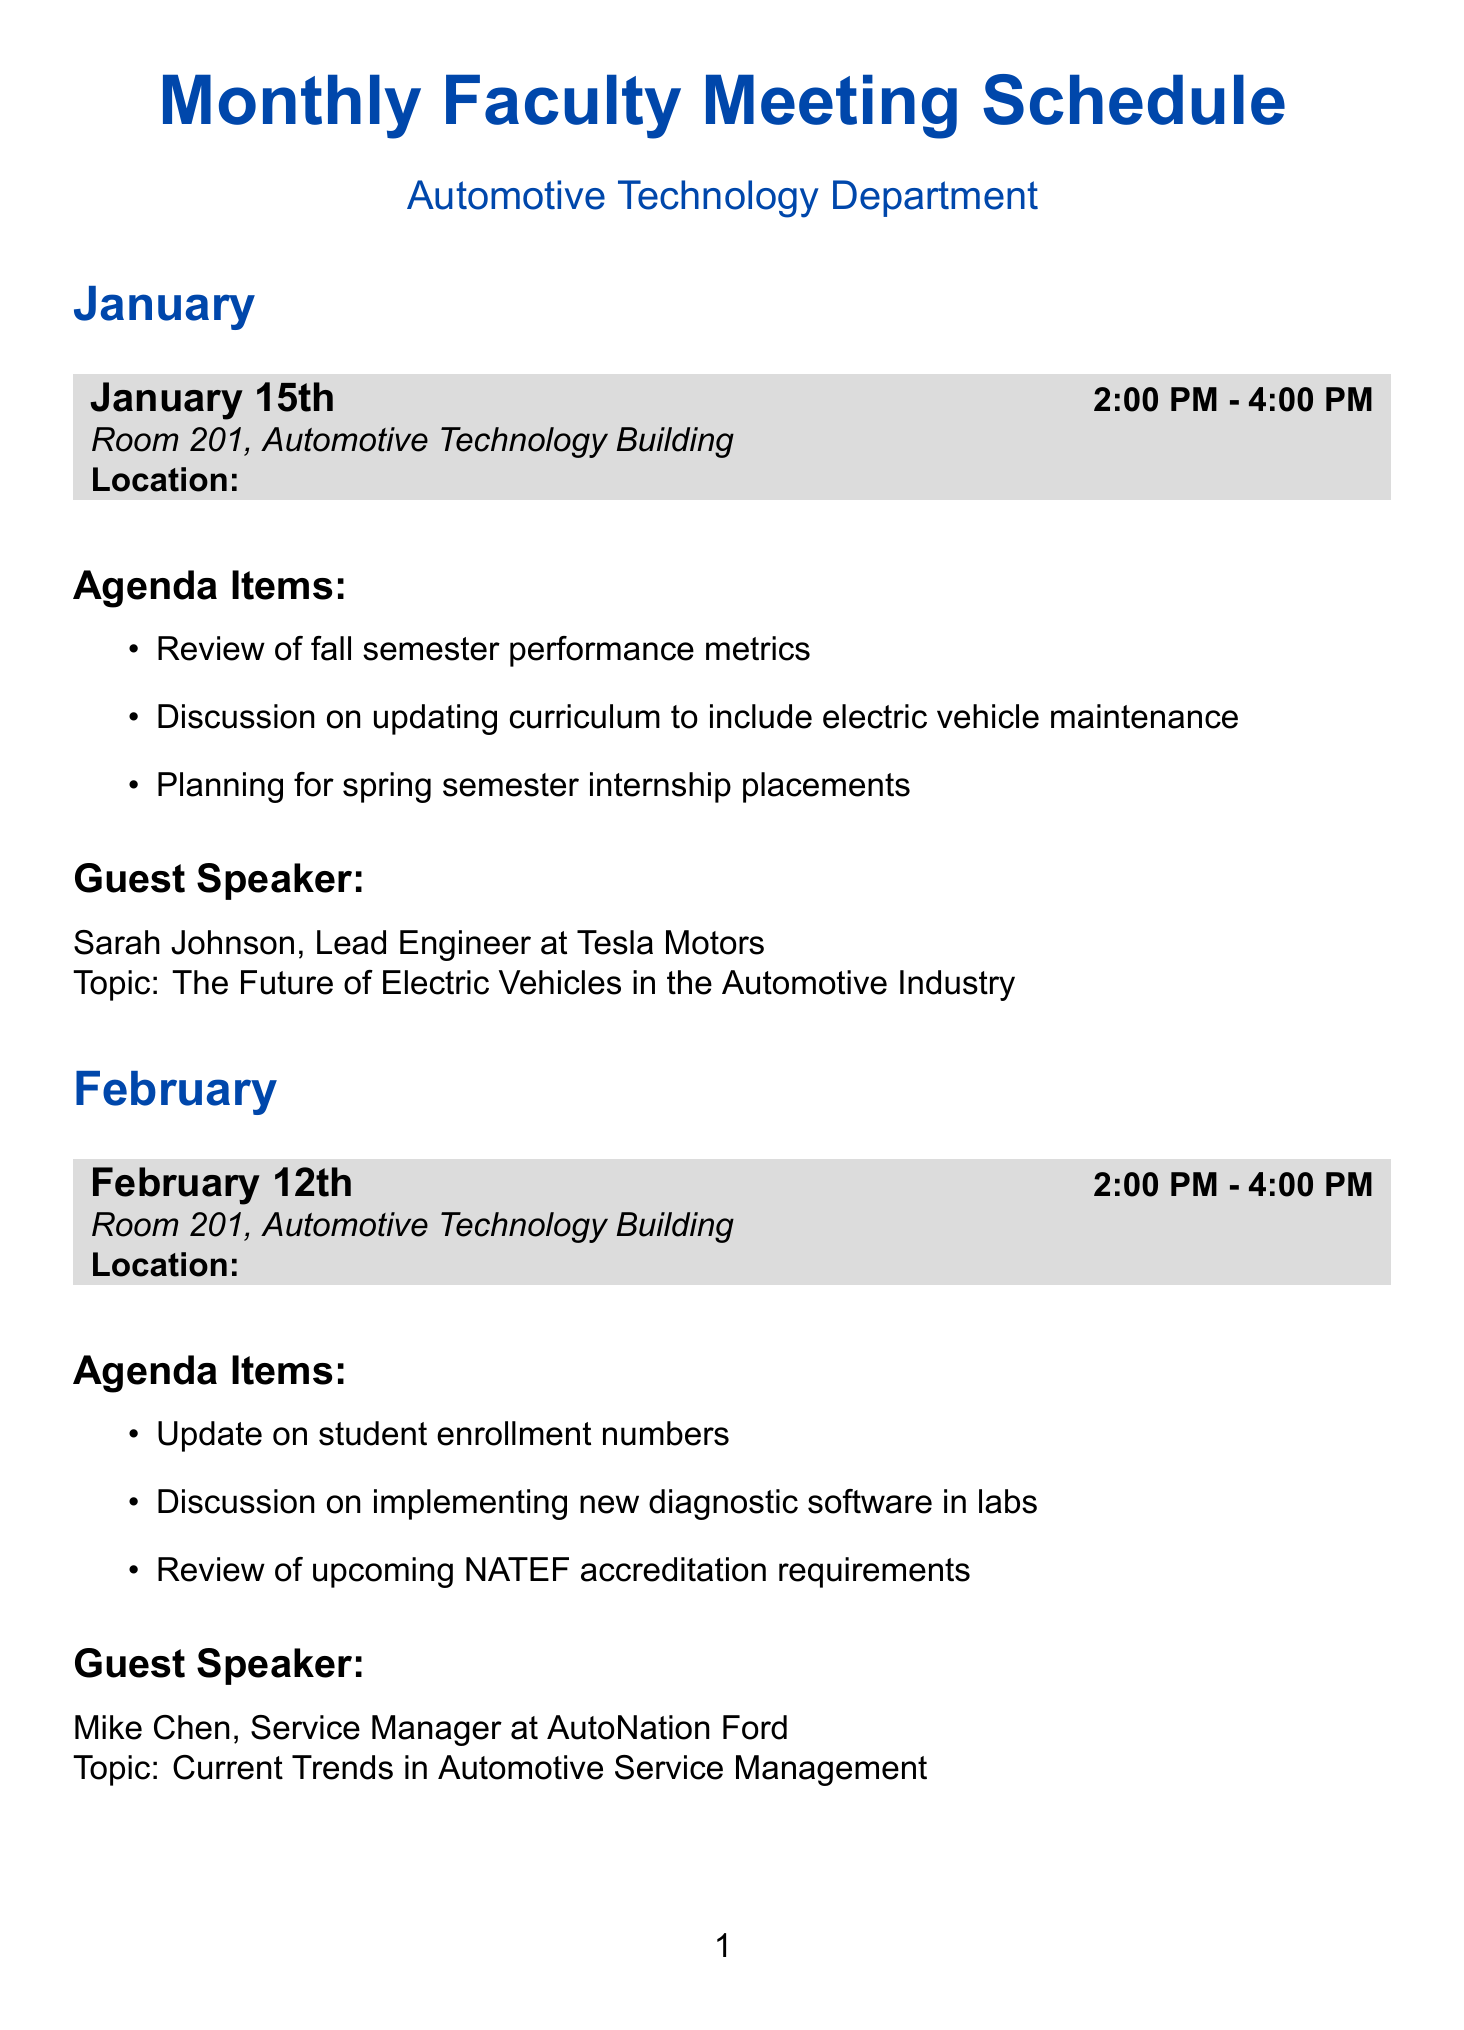What is the date of the January meeting? The date of the January meeting can be found in the schedule, which states "January 15th."
Answer: January 15th Who is the guest speaker for February? The guest speaker for February is listed as "Mike Chen."
Answer: Mike Chen What topic will Lisa Patel discuss in May? Lisa Patel's topic is mentioned in the agenda as "Skills and Qualities Sought in Entry-Level Automotive Technicians."
Answer: Skills and Qualities Sought in Entry-Level Automotive Technicians What is the time for the March meeting? The time for the March meeting is detailed in the document as "2:00 PM - 4:00 PM."
Answer: 2:00 PM - 4:00 PM Which company does Sarah Johnson represent? Sarah Johnson's company is noted in the document as "Tesla Motors."
Answer: Tesla Motors What is the main discussion topic for the April meeting? The document indicates that the agenda item includes "Discussion on summer course offerings," which is a main topic for April.
Answer: Discussion on summer course offerings How many meetings are scheduled from January to May? By counting the listed meetings in the document, there are five meetings from January to May.
Answer: 5 What is being reviewed in the February meeting? The agenda for February includes "Review of upcoming NATEF accreditation requirements," indicating what will be reviewed.
Answer: Review of upcoming NATEF accreditation requirements Which title does Emily Rodriguez hold? Emily Rodriguez is introduced in the document as "Training Coordinator."
Answer: Training Coordinator 